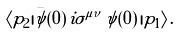<formula> <loc_0><loc_0><loc_500><loc_500>\langle p _ { 2 } | \bar { \psi } ( 0 ) \, i \sigma ^ { \mu \nu } \, \psi ( 0 ) \, | p _ { 1 } \rangle \, .</formula> 